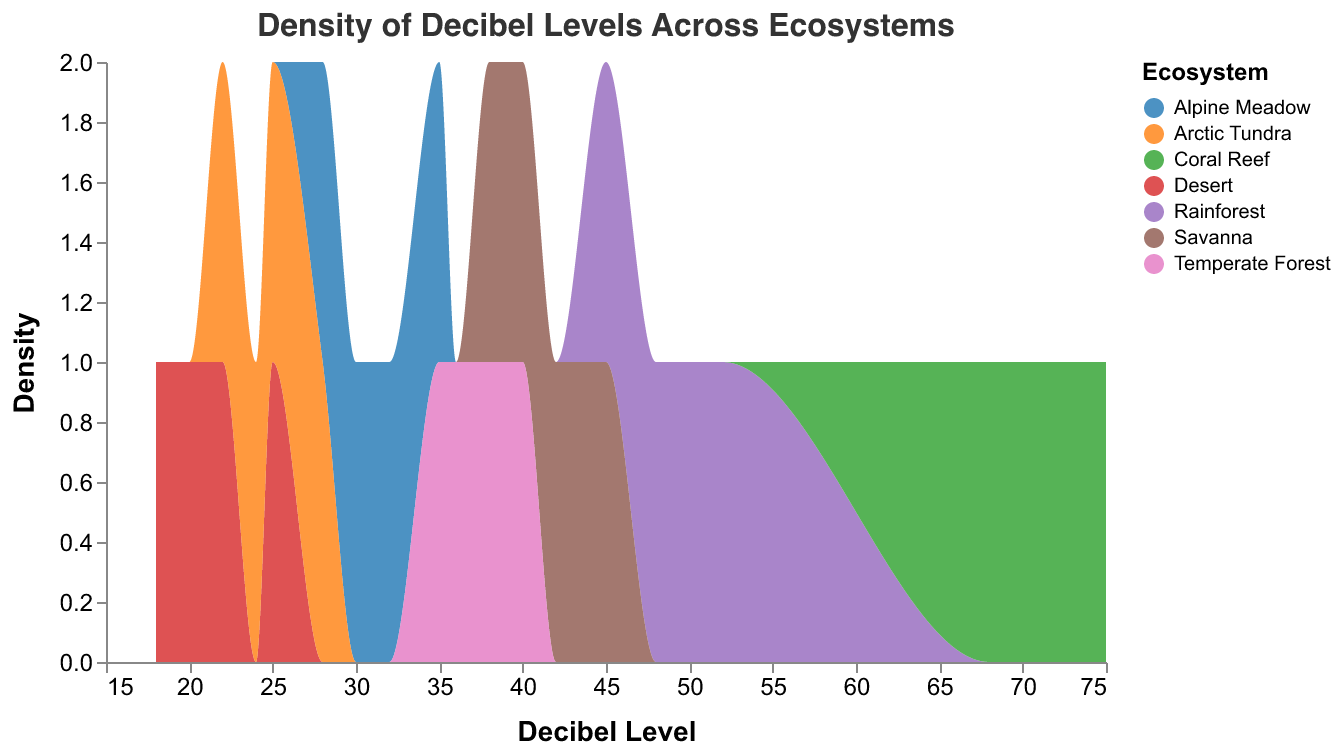What is the title of the figure? The title is clearly displayed at the top of the figure.
Answer: Density of Decibel Levels Across Ecosystems What is the range of decibel levels for the Desert ecosystem? By looking at the portion of the density plot corresponding to the Desert ecosystem, we see the range is from 18 to 25 decibels.
Answer: 18-25 Which ecosystem has the highest decibel levels? The Coral Reef section of the density plot shows the highest decibel levels, which range from 68 to 75 decibels.
Answer: Coral Reef Which ecosystem has the lowest decibel levels? The Desert ecosystem is visually identified by the lowest portion of decibel levels in the density plot, ranging from 18 to 25 decibels.
Answer: Desert How do the decibel level ranges of the Rainforest and Savanna compare? The Rainforest decibel levels range from 45 to 52, while the Savanna ranges from 38 to 45. The Rainforest has generally higher decibel levels compared to the Savanna.
Answer: Rainforest decibel levels are generally higher Which ecosystems overlap in decibel levels? By observing the density plot where the areas of different ecosystems superimpose, it is evident that the Alpine Meadow, Temperate Forest, and Arctic Tundra have overlapping ranges around 28-36 decibels.
Answer: Alpine Meadow, Temperate Forest, and Arctic Tundra What is the decibel range of the Temperate Forest ecosystem? The density plot shows that the Temperate Forest ecosystem has decibel levels ranging from 35 to 40.
Answer: 35-40 Which ecosystem has the highest density of decibel levels in the range of 20 to 30 decibels? Observing the density within this range, the Desert and Arctic Tundra both have decibel levels peaking within this range. However, the density is higher for the Desert.
Answer: Desert 